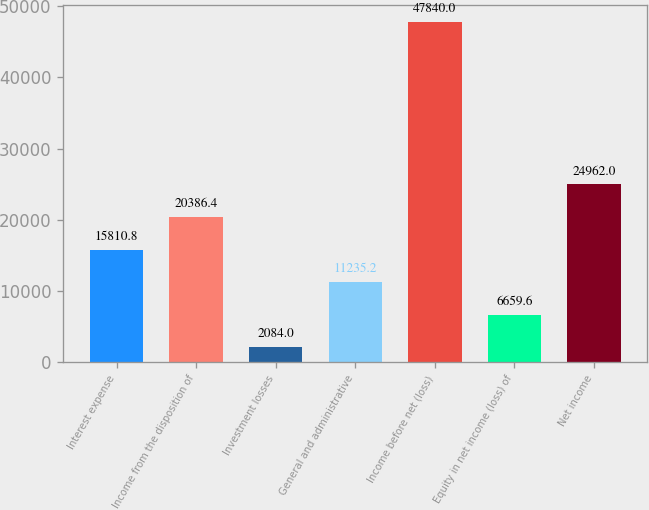<chart> <loc_0><loc_0><loc_500><loc_500><bar_chart><fcel>Interest expense<fcel>Income from the disposition of<fcel>Investment losses<fcel>General and administrative<fcel>Income before net (loss)<fcel>Equity in net income (loss) of<fcel>Net income<nl><fcel>15810.8<fcel>20386.4<fcel>2084<fcel>11235.2<fcel>47840<fcel>6659.6<fcel>24962<nl></chart> 